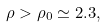<formula> <loc_0><loc_0><loc_500><loc_500>\rho > \rho _ { 0 } \simeq 2 . 3 ,</formula> 